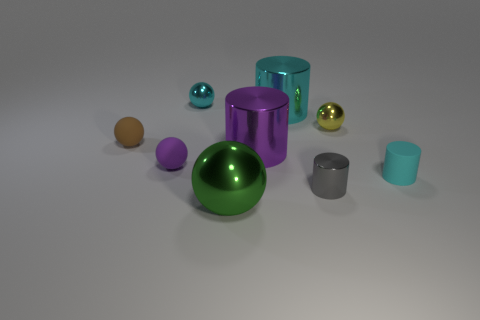What material is the sphere on the left side of the rubber ball that is on the right side of the rubber ball behind the purple matte thing?
Offer a very short reply. Rubber. Are there the same number of big purple metallic cylinders right of the tiny gray shiny cylinder and green shiny spheres?
Make the answer very short. No. Are the small ball that is in front of the small brown rubber sphere and the cyan object that is in front of the small purple matte object made of the same material?
Your answer should be very brief. Yes. Are there any other things that have the same material as the purple sphere?
Make the answer very short. Yes. Is the shape of the purple metal thing that is left of the cyan matte cylinder the same as the green thing that is on the right side of the purple matte sphere?
Your answer should be very brief. No. Is the number of tiny gray cylinders that are in front of the green metallic object less than the number of purple blocks?
Your response must be concise. No. How many tiny metallic cylinders have the same color as the big metal sphere?
Your response must be concise. 0. There is a sphere that is to the right of the green ball; what is its size?
Your answer should be very brief. Small. The purple object on the right side of the small metal thing behind the large metallic thing behind the brown matte sphere is what shape?
Give a very brief answer. Cylinder. There is a metallic object that is both behind the gray object and in front of the brown rubber ball; what is its shape?
Your response must be concise. Cylinder. 